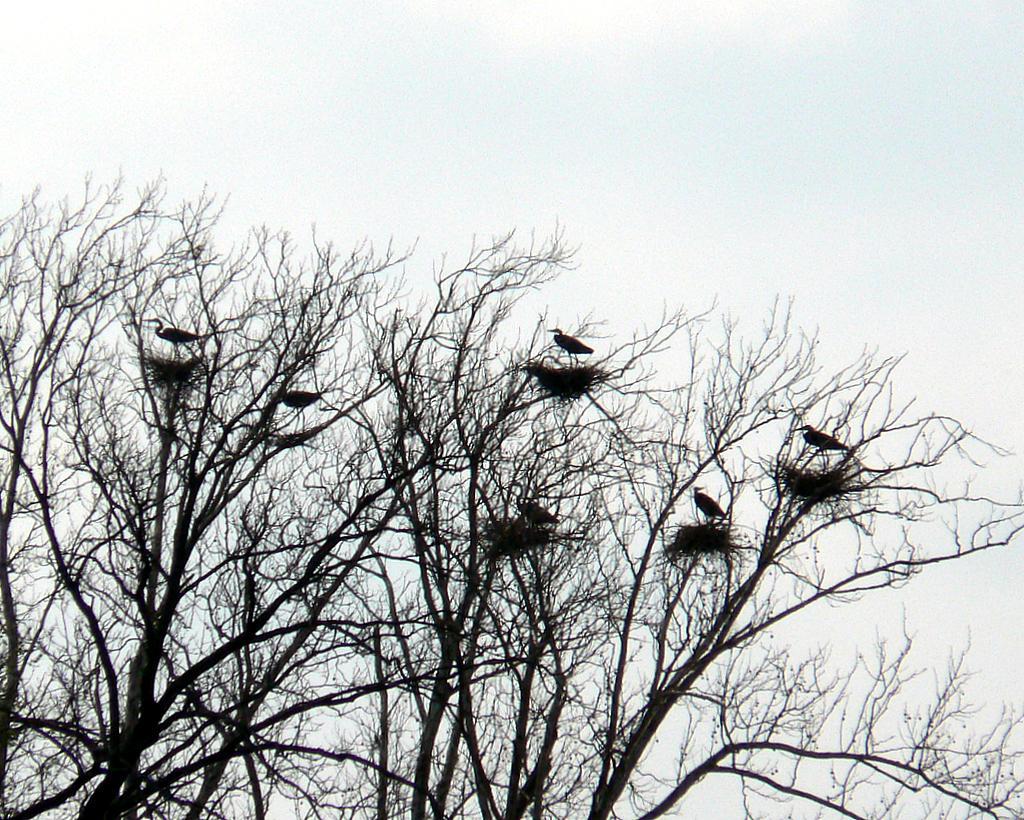In one or two sentences, can you explain what this image depicts? In this image I can see the tree. On the tree I can see the birds. In the back there is a sky. 